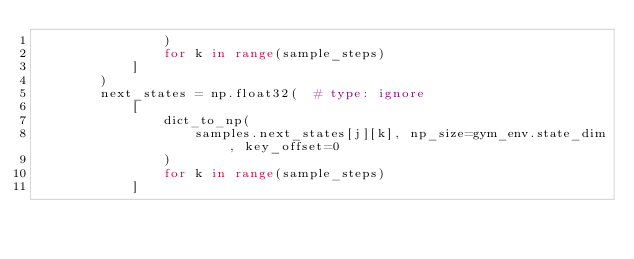Convert code to text. <code><loc_0><loc_0><loc_500><loc_500><_Python_>                )
                for k in range(sample_steps)
            ]
        )
        next_states = np.float32(  # type: ignore
            [
                dict_to_np(
                    samples.next_states[j][k], np_size=gym_env.state_dim, key_offset=0
                )
                for k in range(sample_steps)
            ]</code> 